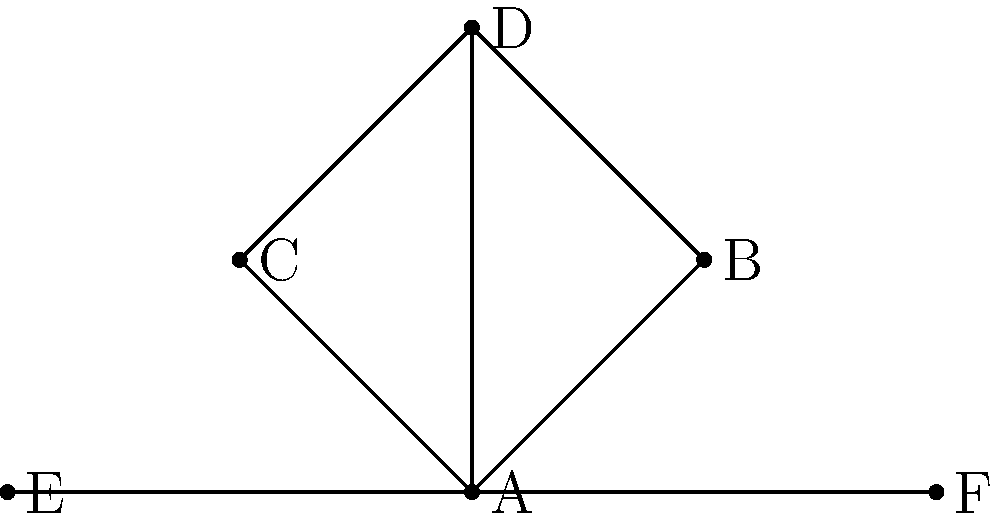In the network diagram representing character relationships in your novel, which character has the highest degree centrality (most direct connections)? How might this impact the story's progression and character development? To answer this question, we need to follow these steps:

1. Understand degree centrality:
   Degree centrality is a measure of the number of direct connections a node (character) has in a network.

2. Count connections for each character:
   A: 5 connections (B, C, D, E, F)
   B: 2 connections (A, D)
   C: 2 connections (A, D)
   D: 3 connections (A, B, C)
   E: 1 connection (A)
   F: 1 connection (A)

3. Identify the character with the highest degree centrality:
   Character A has the most connections (5), making it the character with the highest degree centrality.

4. Consider the impact on story progression and character development:
   - The central character (A) likely plays a pivotal role in the plot, connecting various subplots and character arcs.
   - This character may face more conflicts or challenges due to their many relationships.
   - Character A could be a source of information or gossip, influencing other characters' actions and decisions.
   - The story may explore how this character balances multiple relationships and the resulting personal growth.
   - Secondary characters might develop through their interactions with the central character.

5. Reflect on how this network structure could help overcome writer's block:
   - Use the central character as a starting point for new plot ideas or character interactions.
   - Explore the potential for conflict or collaboration between characters connected through A.
   - Develop backstories for the relationships between A and other characters.
Answer: Character A; central role in plot, potential for multiple conflicts and character interactions 